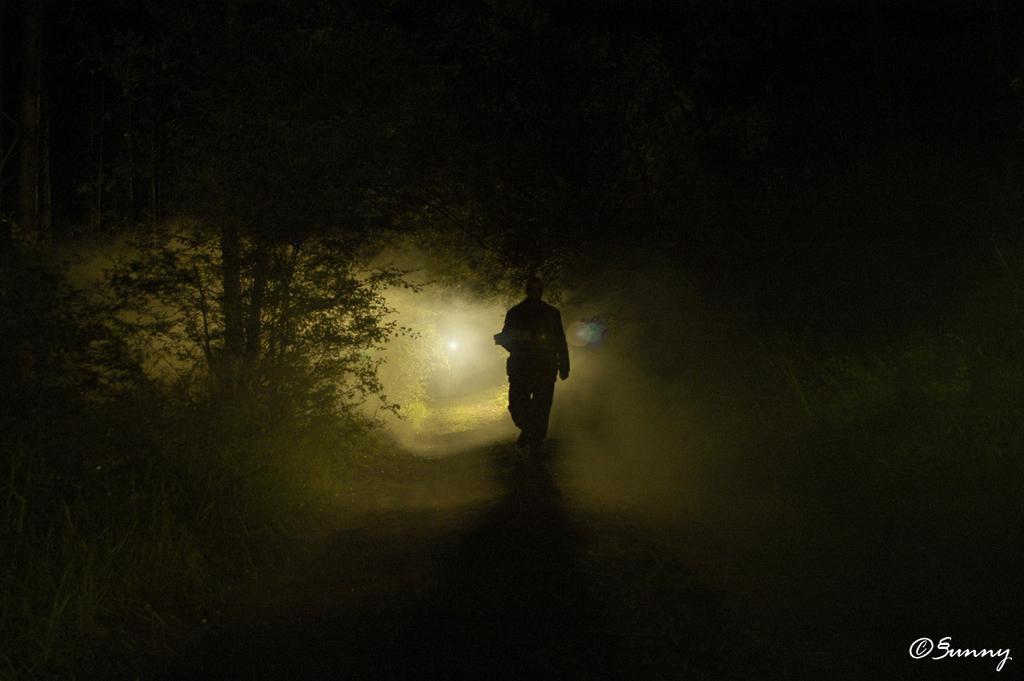How would you summarize this image in a sentence or two? In this image, we can see a person walking on a path. There is a tree on the left side of the image. 